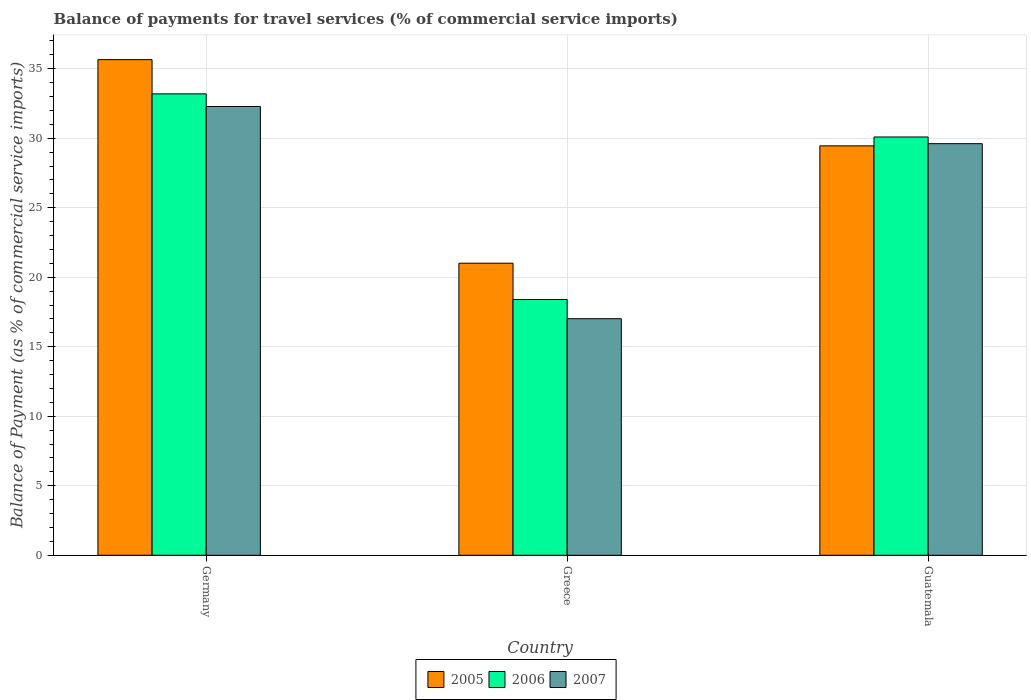How many groups of bars are there?
Offer a very short reply. 3. How many bars are there on the 3rd tick from the left?
Offer a very short reply. 3. How many bars are there on the 1st tick from the right?
Ensure brevity in your answer.  3. What is the balance of payments for travel services in 2007 in Guatemala?
Offer a terse response. 29.61. Across all countries, what is the maximum balance of payments for travel services in 2005?
Offer a very short reply. 35.65. Across all countries, what is the minimum balance of payments for travel services in 2006?
Offer a terse response. 18.4. In which country was the balance of payments for travel services in 2005 minimum?
Offer a terse response. Greece. What is the total balance of payments for travel services in 2005 in the graph?
Provide a short and direct response. 86.11. What is the difference between the balance of payments for travel services in 2006 in Germany and that in Guatemala?
Give a very brief answer. 3.1. What is the difference between the balance of payments for travel services in 2005 in Greece and the balance of payments for travel services in 2007 in Guatemala?
Offer a very short reply. -8.6. What is the average balance of payments for travel services in 2007 per country?
Provide a short and direct response. 26.3. What is the difference between the balance of payments for travel services of/in 2007 and balance of payments for travel services of/in 2005 in Greece?
Offer a very short reply. -3.99. What is the ratio of the balance of payments for travel services in 2006 in Germany to that in Greece?
Keep it short and to the point. 1.8. Is the difference between the balance of payments for travel services in 2007 in Germany and Greece greater than the difference between the balance of payments for travel services in 2005 in Germany and Greece?
Your answer should be very brief. Yes. What is the difference between the highest and the second highest balance of payments for travel services in 2005?
Make the answer very short. -14.64. What is the difference between the highest and the lowest balance of payments for travel services in 2007?
Offer a very short reply. 15.27. In how many countries, is the balance of payments for travel services in 2005 greater than the average balance of payments for travel services in 2005 taken over all countries?
Offer a very short reply. 2. Is the sum of the balance of payments for travel services in 2007 in Germany and Guatemala greater than the maximum balance of payments for travel services in 2005 across all countries?
Your response must be concise. Yes. What does the 1st bar from the right in Greece represents?
Your response must be concise. 2007. Is it the case that in every country, the sum of the balance of payments for travel services in 2006 and balance of payments for travel services in 2005 is greater than the balance of payments for travel services in 2007?
Your answer should be compact. Yes. Are all the bars in the graph horizontal?
Offer a very short reply. No. How many countries are there in the graph?
Make the answer very short. 3. What is the difference between two consecutive major ticks on the Y-axis?
Ensure brevity in your answer.  5. Does the graph contain grids?
Keep it short and to the point. Yes. What is the title of the graph?
Offer a very short reply. Balance of payments for travel services (% of commercial service imports). What is the label or title of the Y-axis?
Offer a terse response. Balance of Payment (as % of commercial service imports). What is the Balance of Payment (as % of commercial service imports) in 2005 in Germany?
Offer a very short reply. 35.65. What is the Balance of Payment (as % of commercial service imports) in 2006 in Germany?
Keep it short and to the point. 33.19. What is the Balance of Payment (as % of commercial service imports) in 2007 in Germany?
Keep it short and to the point. 32.28. What is the Balance of Payment (as % of commercial service imports) of 2005 in Greece?
Give a very brief answer. 21.01. What is the Balance of Payment (as % of commercial service imports) of 2006 in Greece?
Give a very brief answer. 18.4. What is the Balance of Payment (as % of commercial service imports) in 2007 in Greece?
Your response must be concise. 17.02. What is the Balance of Payment (as % of commercial service imports) in 2005 in Guatemala?
Give a very brief answer. 29.45. What is the Balance of Payment (as % of commercial service imports) of 2006 in Guatemala?
Offer a terse response. 30.09. What is the Balance of Payment (as % of commercial service imports) in 2007 in Guatemala?
Your answer should be compact. 29.61. Across all countries, what is the maximum Balance of Payment (as % of commercial service imports) of 2005?
Offer a very short reply. 35.65. Across all countries, what is the maximum Balance of Payment (as % of commercial service imports) in 2006?
Your answer should be compact. 33.19. Across all countries, what is the maximum Balance of Payment (as % of commercial service imports) of 2007?
Provide a succinct answer. 32.28. Across all countries, what is the minimum Balance of Payment (as % of commercial service imports) in 2005?
Ensure brevity in your answer.  21.01. Across all countries, what is the minimum Balance of Payment (as % of commercial service imports) of 2006?
Give a very brief answer. 18.4. Across all countries, what is the minimum Balance of Payment (as % of commercial service imports) of 2007?
Your answer should be very brief. 17.02. What is the total Balance of Payment (as % of commercial service imports) of 2005 in the graph?
Ensure brevity in your answer.  86.11. What is the total Balance of Payment (as % of commercial service imports) in 2006 in the graph?
Your response must be concise. 81.68. What is the total Balance of Payment (as % of commercial service imports) of 2007 in the graph?
Your answer should be very brief. 78.91. What is the difference between the Balance of Payment (as % of commercial service imports) in 2005 in Germany and that in Greece?
Keep it short and to the point. 14.64. What is the difference between the Balance of Payment (as % of commercial service imports) in 2006 in Germany and that in Greece?
Ensure brevity in your answer.  14.79. What is the difference between the Balance of Payment (as % of commercial service imports) in 2007 in Germany and that in Greece?
Give a very brief answer. 15.27. What is the difference between the Balance of Payment (as % of commercial service imports) in 2005 in Germany and that in Guatemala?
Make the answer very short. 6.2. What is the difference between the Balance of Payment (as % of commercial service imports) of 2006 in Germany and that in Guatemala?
Your response must be concise. 3.1. What is the difference between the Balance of Payment (as % of commercial service imports) of 2007 in Germany and that in Guatemala?
Offer a very short reply. 2.67. What is the difference between the Balance of Payment (as % of commercial service imports) in 2005 in Greece and that in Guatemala?
Ensure brevity in your answer.  -8.44. What is the difference between the Balance of Payment (as % of commercial service imports) of 2006 in Greece and that in Guatemala?
Your answer should be very brief. -11.69. What is the difference between the Balance of Payment (as % of commercial service imports) of 2007 in Greece and that in Guatemala?
Offer a terse response. -12.59. What is the difference between the Balance of Payment (as % of commercial service imports) in 2005 in Germany and the Balance of Payment (as % of commercial service imports) in 2006 in Greece?
Ensure brevity in your answer.  17.25. What is the difference between the Balance of Payment (as % of commercial service imports) in 2005 in Germany and the Balance of Payment (as % of commercial service imports) in 2007 in Greece?
Provide a short and direct response. 18.63. What is the difference between the Balance of Payment (as % of commercial service imports) of 2006 in Germany and the Balance of Payment (as % of commercial service imports) of 2007 in Greece?
Provide a short and direct response. 16.17. What is the difference between the Balance of Payment (as % of commercial service imports) of 2005 in Germany and the Balance of Payment (as % of commercial service imports) of 2006 in Guatemala?
Your answer should be very brief. 5.56. What is the difference between the Balance of Payment (as % of commercial service imports) of 2005 in Germany and the Balance of Payment (as % of commercial service imports) of 2007 in Guatemala?
Give a very brief answer. 6.04. What is the difference between the Balance of Payment (as % of commercial service imports) of 2006 in Germany and the Balance of Payment (as % of commercial service imports) of 2007 in Guatemala?
Your answer should be compact. 3.58. What is the difference between the Balance of Payment (as % of commercial service imports) of 2005 in Greece and the Balance of Payment (as % of commercial service imports) of 2006 in Guatemala?
Your answer should be compact. -9.08. What is the difference between the Balance of Payment (as % of commercial service imports) of 2005 in Greece and the Balance of Payment (as % of commercial service imports) of 2007 in Guatemala?
Give a very brief answer. -8.6. What is the difference between the Balance of Payment (as % of commercial service imports) in 2006 in Greece and the Balance of Payment (as % of commercial service imports) in 2007 in Guatemala?
Provide a short and direct response. -11.21. What is the average Balance of Payment (as % of commercial service imports) of 2005 per country?
Provide a succinct answer. 28.7. What is the average Balance of Payment (as % of commercial service imports) of 2006 per country?
Offer a very short reply. 27.23. What is the average Balance of Payment (as % of commercial service imports) of 2007 per country?
Give a very brief answer. 26.3. What is the difference between the Balance of Payment (as % of commercial service imports) in 2005 and Balance of Payment (as % of commercial service imports) in 2006 in Germany?
Offer a very short reply. 2.46. What is the difference between the Balance of Payment (as % of commercial service imports) in 2005 and Balance of Payment (as % of commercial service imports) in 2007 in Germany?
Keep it short and to the point. 3.37. What is the difference between the Balance of Payment (as % of commercial service imports) of 2006 and Balance of Payment (as % of commercial service imports) of 2007 in Germany?
Provide a succinct answer. 0.91. What is the difference between the Balance of Payment (as % of commercial service imports) in 2005 and Balance of Payment (as % of commercial service imports) in 2006 in Greece?
Provide a succinct answer. 2.61. What is the difference between the Balance of Payment (as % of commercial service imports) of 2005 and Balance of Payment (as % of commercial service imports) of 2007 in Greece?
Offer a very short reply. 3.99. What is the difference between the Balance of Payment (as % of commercial service imports) of 2006 and Balance of Payment (as % of commercial service imports) of 2007 in Greece?
Your answer should be very brief. 1.38. What is the difference between the Balance of Payment (as % of commercial service imports) of 2005 and Balance of Payment (as % of commercial service imports) of 2006 in Guatemala?
Make the answer very short. -0.64. What is the difference between the Balance of Payment (as % of commercial service imports) in 2005 and Balance of Payment (as % of commercial service imports) in 2007 in Guatemala?
Provide a short and direct response. -0.16. What is the difference between the Balance of Payment (as % of commercial service imports) in 2006 and Balance of Payment (as % of commercial service imports) in 2007 in Guatemala?
Provide a short and direct response. 0.48. What is the ratio of the Balance of Payment (as % of commercial service imports) in 2005 in Germany to that in Greece?
Offer a very short reply. 1.7. What is the ratio of the Balance of Payment (as % of commercial service imports) of 2006 in Germany to that in Greece?
Offer a very short reply. 1.8. What is the ratio of the Balance of Payment (as % of commercial service imports) in 2007 in Germany to that in Greece?
Offer a very short reply. 1.9. What is the ratio of the Balance of Payment (as % of commercial service imports) of 2005 in Germany to that in Guatemala?
Give a very brief answer. 1.21. What is the ratio of the Balance of Payment (as % of commercial service imports) of 2006 in Germany to that in Guatemala?
Provide a short and direct response. 1.1. What is the ratio of the Balance of Payment (as % of commercial service imports) of 2007 in Germany to that in Guatemala?
Your response must be concise. 1.09. What is the ratio of the Balance of Payment (as % of commercial service imports) of 2005 in Greece to that in Guatemala?
Keep it short and to the point. 0.71. What is the ratio of the Balance of Payment (as % of commercial service imports) in 2006 in Greece to that in Guatemala?
Your answer should be very brief. 0.61. What is the ratio of the Balance of Payment (as % of commercial service imports) of 2007 in Greece to that in Guatemala?
Make the answer very short. 0.57. What is the difference between the highest and the second highest Balance of Payment (as % of commercial service imports) of 2005?
Keep it short and to the point. 6.2. What is the difference between the highest and the second highest Balance of Payment (as % of commercial service imports) in 2006?
Ensure brevity in your answer.  3.1. What is the difference between the highest and the second highest Balance of Payment (as % of commercial service imports) in 2007?
Your answer should be compact. 2.67. What is the difference between the highest and the lowest Balance of Payment (as % of commercial service imports) of 2005?
Offer a very short reply. 14.64. What is the difference between the highest and the lowest Balance of Payment (as % of commercial service imports) in 2006?
Your answer should be very brief. 14.79. What is the difference between the highest and the lowest Balance of Payment (as % of commercial service imports) in 2007?
Make the answer very short. 15.27. 